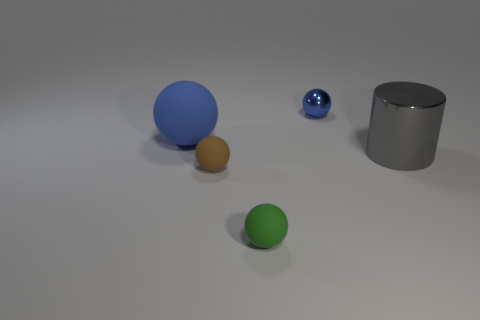What number of other objects are the same material as the gray cylinder? Based on the image, there is one sphere that appears to share the same glossy material as the gray cylinder. So, there is one object made of a similar material. 